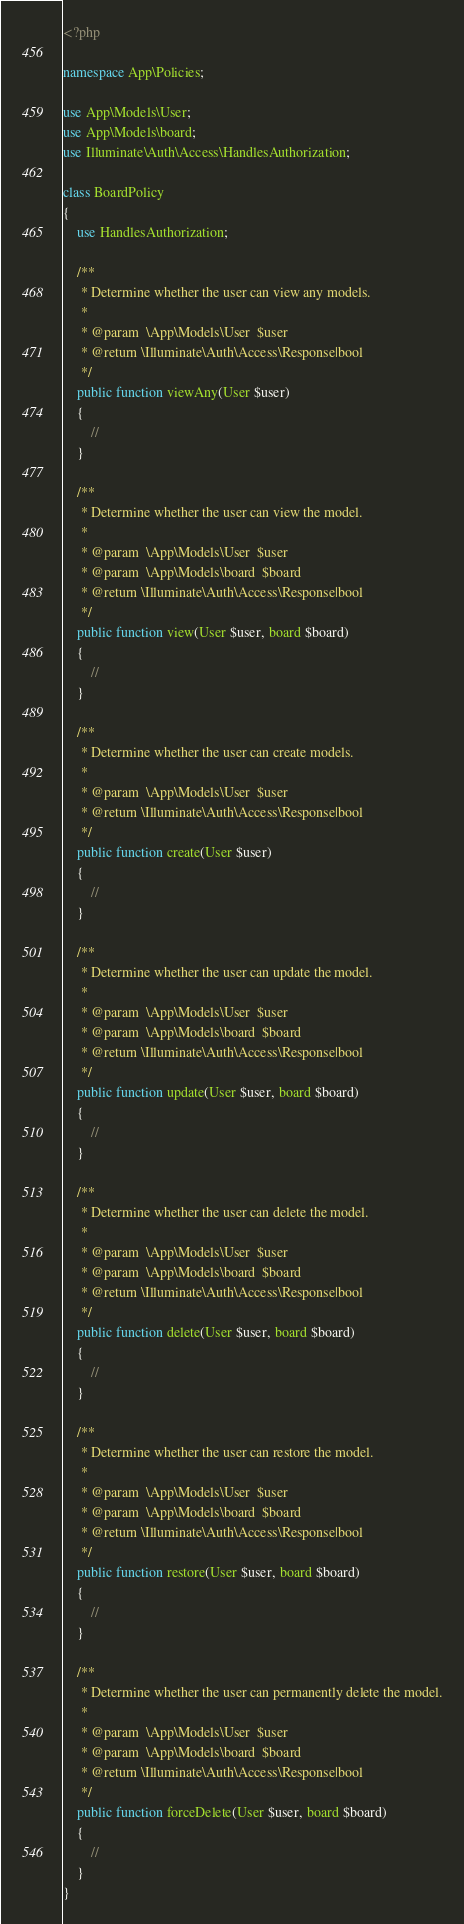Convert code to text. <code><loc_0><loc_0><loc_500><loc_500><_PHP_><?php

namespace App\Policies;

use App\Models\User;
use App\Models\board;
use Illuminate\Auth\Access\HandlesAuthorization;

class BoardPolicy
{
    use HandlesAuthorization;

    /**
     * Determine whether the user can view any models.
     *
     * @param  \App\Models\User  $user
     * @return \Illuminate\Auth\Access\Response|bool
     */
    public function viewAny(User $user)
    {
        //
    }

    /**
     * Determine whether the user can view the model.
     *
     * @param  \App\Models\User  $user
     * @param  \App\Models\board  $board
     * @return \Illuminate\Auth\Access\Response|bool
     */
    public function view(User $user, board $board)
    {
        //
    }

    /**
     * Determine whether the user can create models.
     *
     * @param  \App\Models\User  $user
     * @return \Illuminate\Auth\Access\Response|bool
     */
    public function create(User $user)
    {
        //
    }

    /**
     * Determine whether the user can update the model.
     *
     * @param  \App\Models\User  $user
     * @param  \App\Models\board  $board
     * @return \Illuminate\Auth\Access\Response|bool
     */
    public function update(User $user, board $board)
    {
        //
    }

    /**
     * Determine whether the user can delete the model.
     *
     * @param  \App\Models\User  $user
     * @param  \App\Models\board  $board
     * @return \Illuminate\Auth\Access\Response|bool
     */
    public function delete(User $user, board $board)
    {
        //
    }

    /**
     * Determine whether the user can restore the model.
     *
     * @param  \App\Models\User  $user
     * @param  \App\Models\board  $board
     * @return \Illuminate\Auth\Access\Response|bool
     */
    public function restore(User $user, board $board)
    {
        //
    }

    /**
     * Determine whether the user can permanently delete the model.
     *
     * @param  \App\Models\User  $user
     * @param  \App\Models\board  $board
     * @return \Illuminate\Auth\Access\Response|bool
     */
    public function forceDelete(User $user, board $board)
    {
        //
    }
}
</code> 